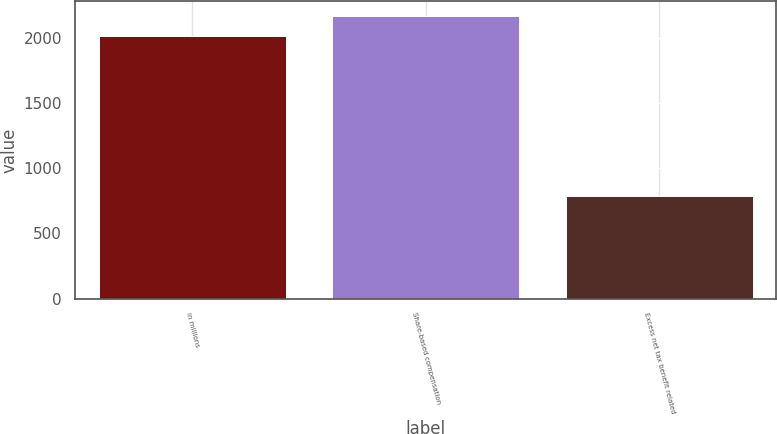<chart> <loc_0><loc_0><loc_500><loc_500><bar_chart><fcel>in millions<fcel>Share-based compensation<fcel>Excess net tax benefit related<nl><fcel>2014<fcel>2169.2<fcel>788<nl></chart> 